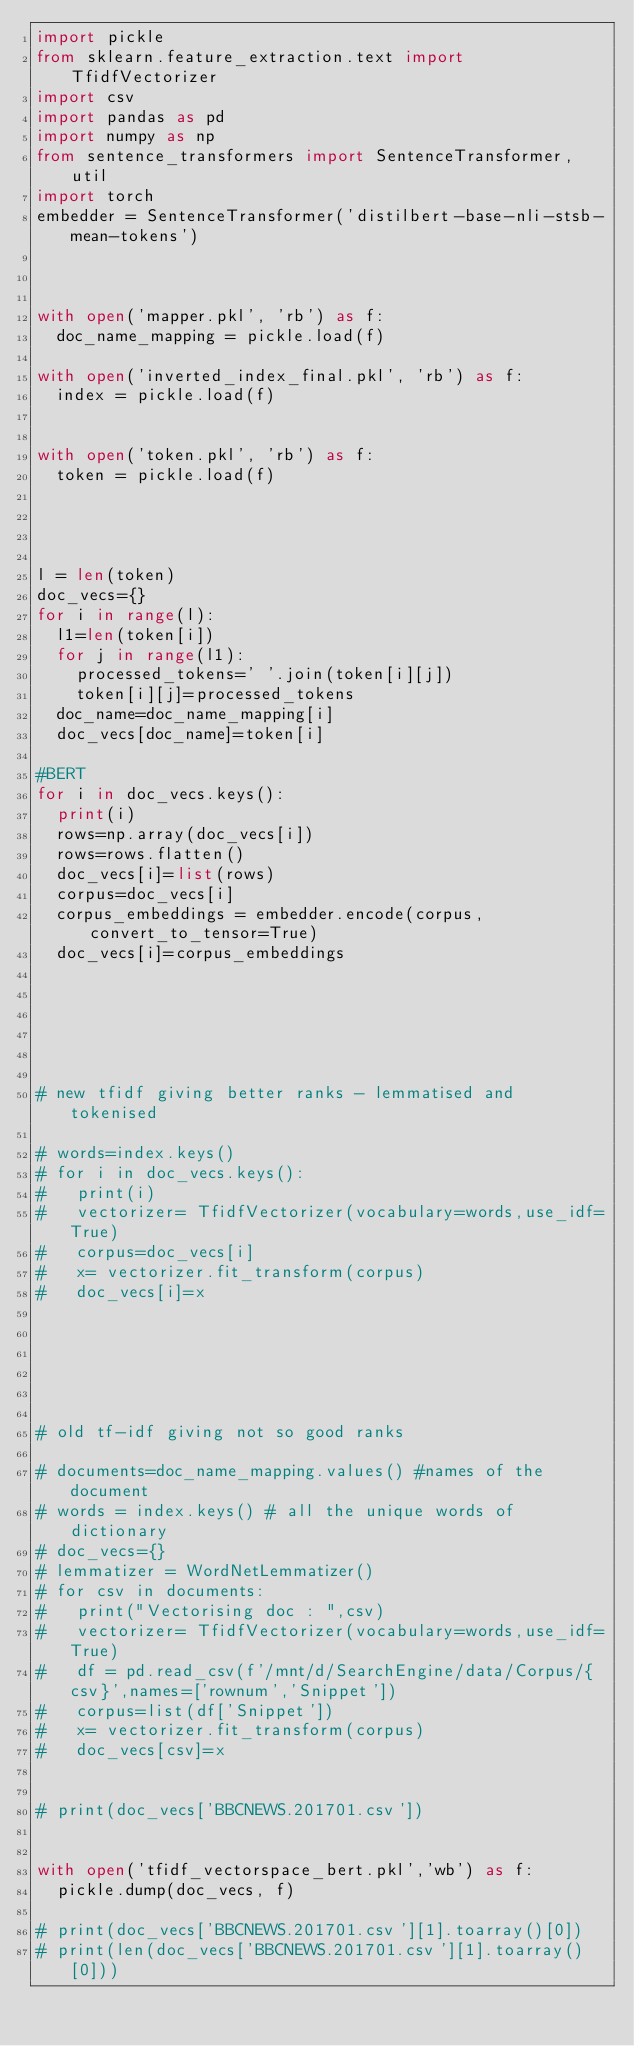<code> <loc_0><loc_0><loc_500><loc_500><_Python_>import pickle
from sklearn.feature_extraction.text import TfidfVectorizer
import csv
import pandas as pd
import numpy as np
from sentence_transformers import SentenceTransformer, util
import torch
embedder = SentenceTransformer('distilbert-base-nli-stsb-mean-tokens')



with open('mapper.pkl', 'rb') as f:
	doc_name_mapping = pickle.load(f)

with open('inverted_index_final.pkl', 'rb') as f:
	index = pickle.load(f)


with open('token.pkl', 'rb') as f:
	token = pickle.load(f)




l = len(token)
doc_vecs={}
for i in range(l):
	l1=len(token[i])
	for j in range(l1):
		processed_tokens=' '.join(token[i][j])
		token[i][j]=processed_tokens
	doc_name=doc_name_mapping[i]
	doc_vecs[doc_name]=token[i]

#BERT
for i in doc_vecs.keys():
	print(i)
	rows=np.array(doc_vecs[i])
	rows=rows.flatten()
	doc_vecs[i]=list(rows)
	corpus=doc_vecs[i]
	corpus_embeddings = embedder.encode(corpus, convert_to_tensor=True)
	doc_vecs[i]=corpus_embeddings
	
	




# new tfidf giving better ranks - lemmatised and tokenised

# words=index.keys()
# for i in doc_vecs.keys():
# 	print(i)
# 	vectorizer= TfidfVectorizer(vocabulary=words,use_idf=True)
# 	corpus=doc_vecs[i]
# 	x= vectorizer.fit_transform(corpus)
# 	doc_vecs[i]=x

	
	
				


# old tf-idf giving not so good ranks	

# documents=doc_name_mapping.values() #names of the document
# words = index.keys() # all the unique words of dictionary 
# doc_vecs={}
# lemmatizer = WordNetLemmatizer()
# for csv in documents:
# 	print("Vectorising doc : ",csv)
# 	vectorizer= TfidfVectorizer(vocabulary=words,use_idf=True)
# 	df = pd.read_csv(f'/mnt/d/SearchEngine/data/Corpus/{csv}',names=['rownum','Snippet'])
# 	corpus=list(df['Snippet'])
# 	x= vectorizer.fit_transform(corpus)
# 	doc_vecs[csv]=x
	
	
# print(doc_vecs['BBCNEWS.201701.csv'])


with open('tfidf_vectorspace_bert.pkl','wb') as f:
	pickle.dump(doc_vecs, f)

# print(doc_vecs['BBCNEWS.201701.csv'][1].toarray()[0])
# print(len(doc_vecs['BBCNEWS.201701.csv'][1].toarray()[0]))

</code> 